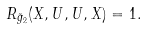Convert formula to latex. <formula><loc_0><loc_0><loc_500><loc_500>R _ { \tilde { g } _ { 2 } } ( X , U , U , X ) = 1 .</formula> 